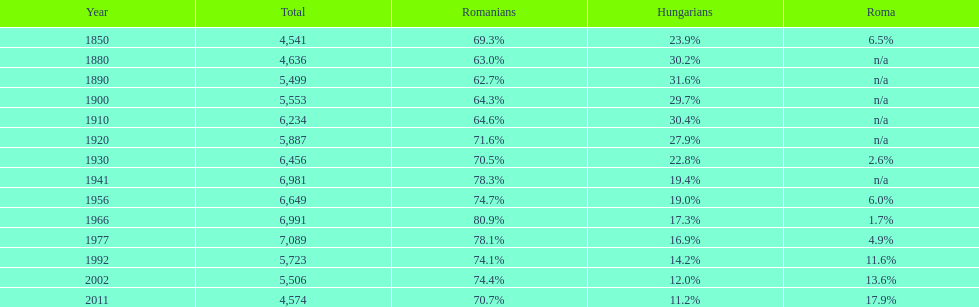Which year witnessed the peak percentage in the romanian population? 1966. 